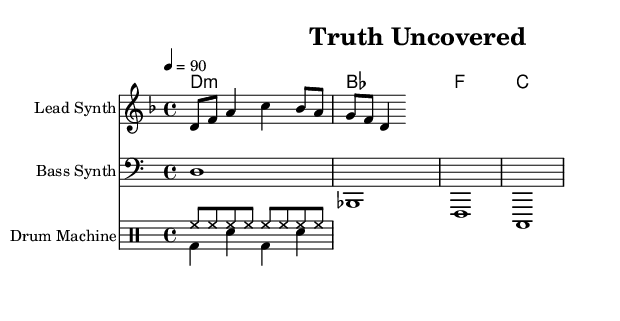What is the key signature of this music? The key signature shows two flats (B♭ and E♭), indicating that it is in D minor.
Answer: D minor What is the time signature of this music? The time signature is found at the beginning of the piece, where it indicates four beats in a measure.
Answer: 4/4 What is the tempo marking of this piece? The tempo is set to a quarter note equals 90, which is indicated on the score.
Answer: 90 What is the first note of the melody? The first note of the melody, as indicated by the staff, is D.
Answer: D How many bars are in the melody? By counting the groupings of notes and following the bar lines, there are seven bars in the melody section.
Answer: 7 What type of instrument is indicated for the bass line? The bass line is designated to be played by a synthesizer based on the instrument name provided in the score.
Answer: Bass Synth Is there a drum pattern present in the music? Yes, there are defined patterns for both hi-hat and bass drum, indicating that percussion is employed in the piece.
Answer: Yes 